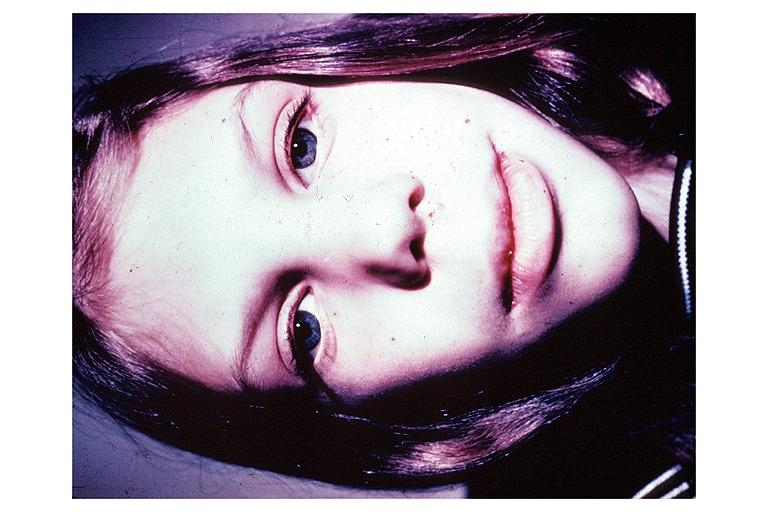s oral present?
Answer the question using a single word or phrase. Yes 